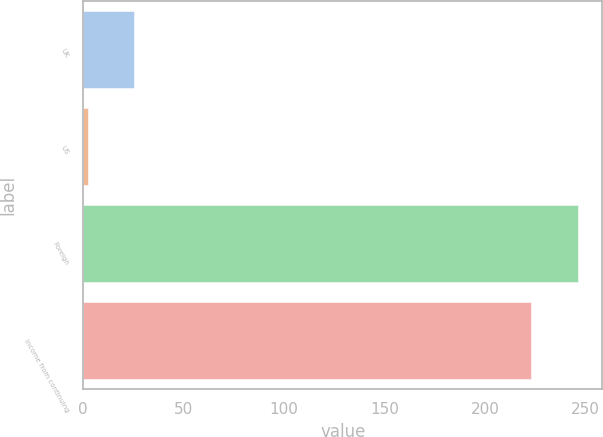Convert chart to OTSL. <chart><loc_0><loc_0><loc_500><loc_500><bar_chart><fcel>UK<fcel>US<fcel>Foreign<fcel>Income from continuing<nl><fcel>25.37<fcel>2.3<fcel>246.17<fcel>223.1<nl></chart> 